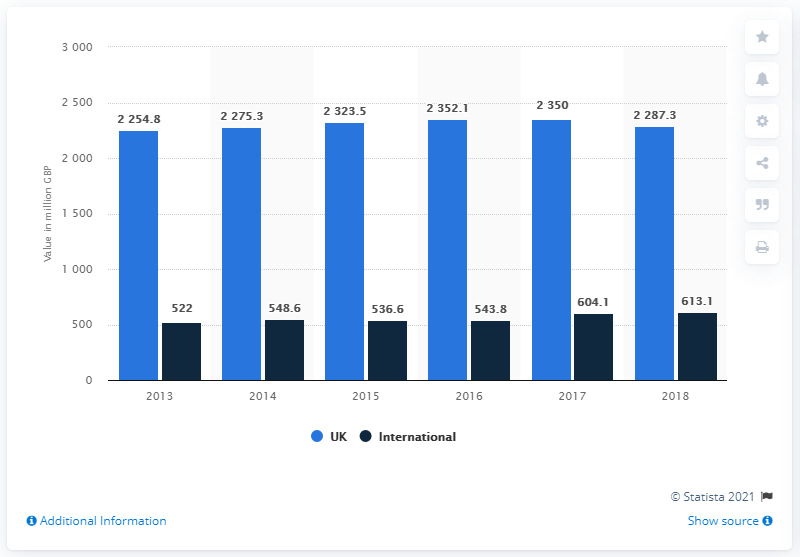Indicate a few pertinent items in this graphic. Debenhams' gross transaction value for the year ending September 1st, 2018 was 2275.3. The average value of international flights over the past 5 years is 561.367. In the United Kingdom, the blue bar represents a commonly used symbol or emblem. 